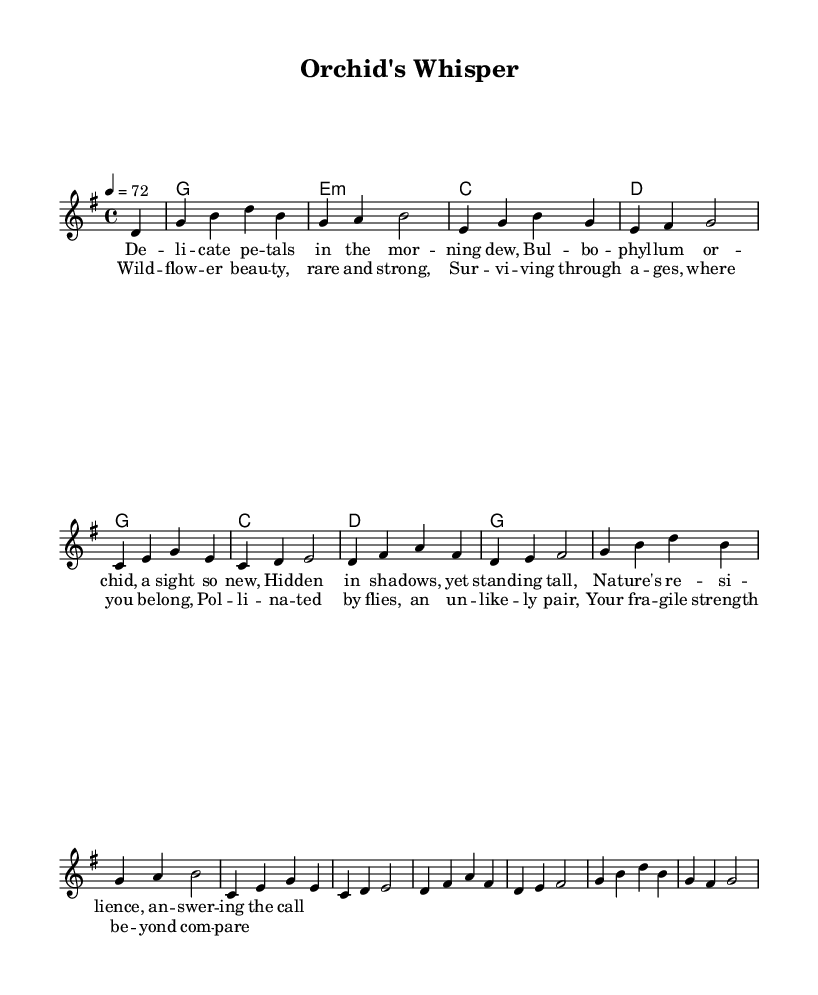What is the key signature of this music? The key signature is indicated by the notes that have sharps or flats. In this case, there are no sharps or flats visible at the beginning of the piece, indicating that the key is G major.
Answer: G major What is the time signature of this music? The time signature is displayed at the beginning of the score. Here, it shows 4/4, which means there are four beats in each measure and the quarter note gets one beat.
Answer: 4/4 What is the tempo marking of this music? The tempo marking is specified in the score, indicating how fast the piece should be played. It is marked as "4 = 72," which means the quarter note is played at a speed of 72 beats per minute.
Answer: 72 How many measures are there in the melody? To determine the number of measures, count the bars present in the melody line. There are eight measures, corresponding to the various lyric lines displayed.
Answer: Eight What is the lyrical theme of the chorus? The chorus lyrically talks about the beauty and resilience of wildflowers, emphasizing their strength and unique relationship with nature. This theme can be seen in the lines about surviving through ages and being pollinated by flies.
Answer: Wildflower beauty What chords accompany the first verse of the song? The chords associated with the first verse can be identified by examining the chord symbols above the corresponding melody line. The chords for the verse include G, E minor, C, and D.
Answer: G, E minor, C, D How many lines of lyrics are in the chorus? The chorus consists of four lines, each corresponding to a musical phrase, and can be counted directly from the score.
Answer: Four 